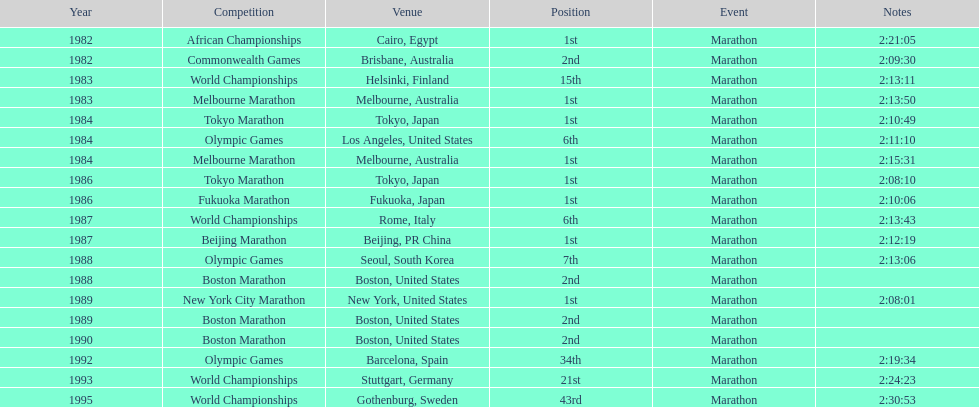What were the number of times the venue was located in the united states? 5. 